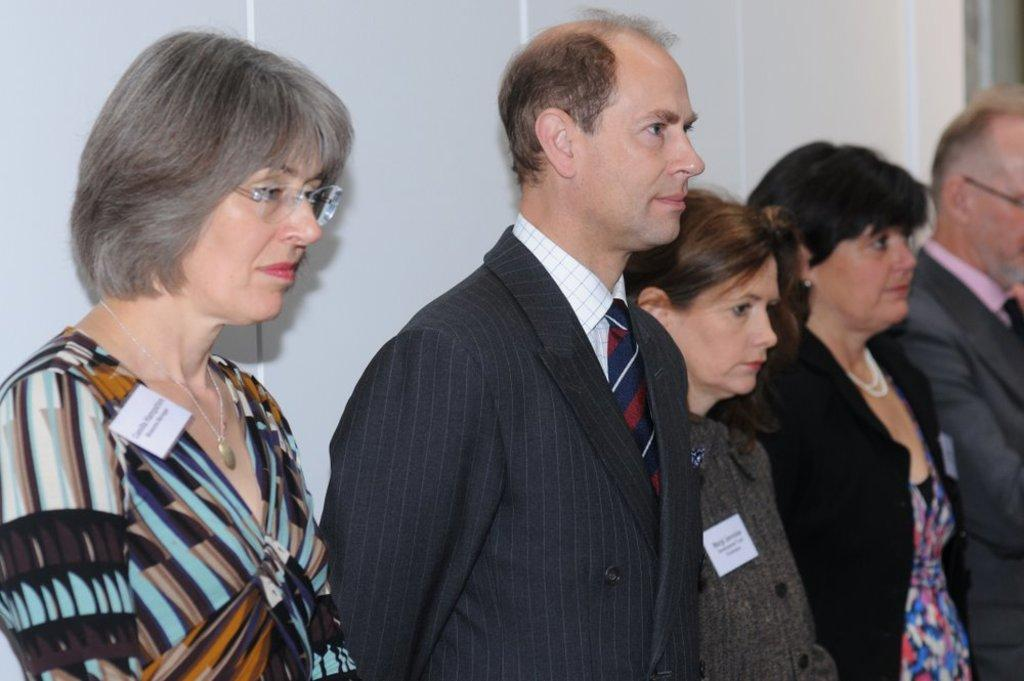How many people are in the image? There is a group of people in the image, but the exact number is not specified. What are the people in the image doing? The people are standing in the image. What direction are the people looking? The people are looking at the right side in the image. Are there any distinguishing features on some of the people? Yes, some of the people are wearing badges. What type of milk is being served at the event in the image? There is no mention of milk or an event in the image. 